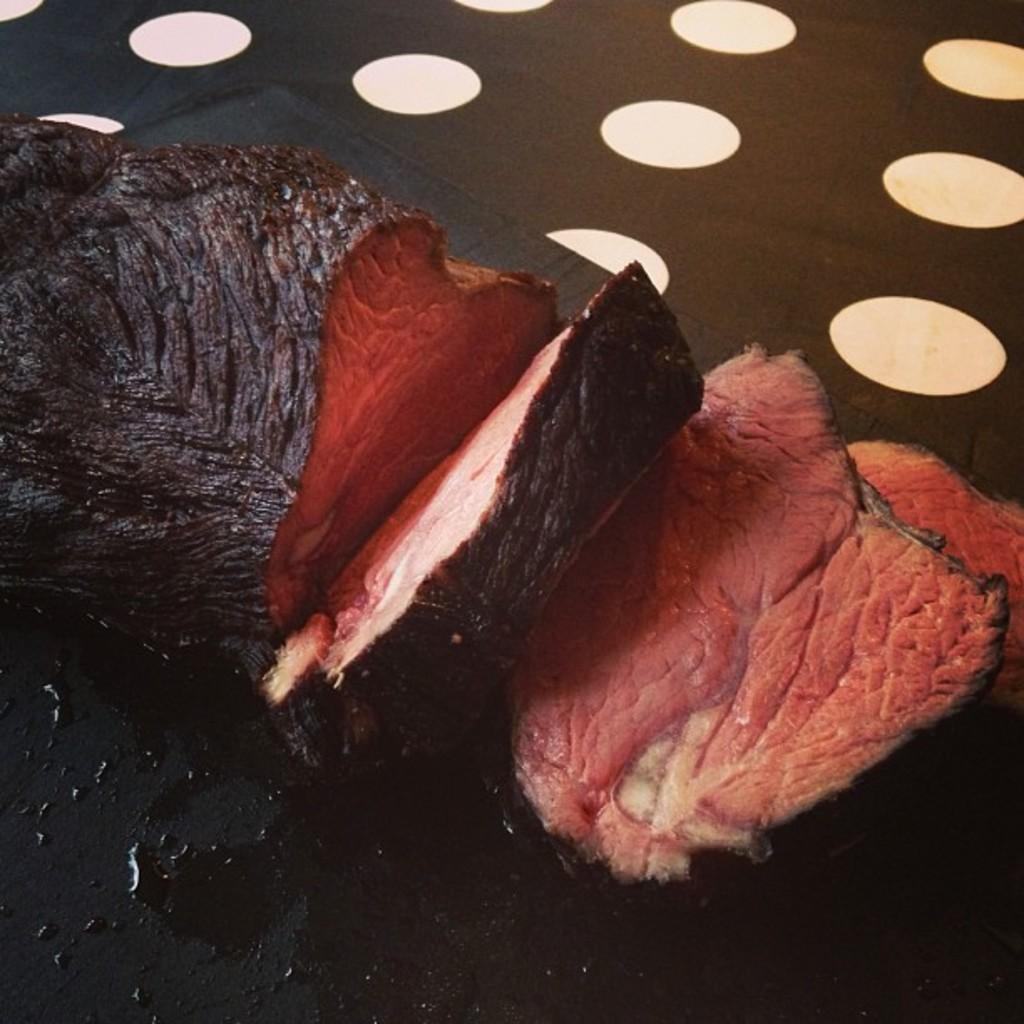Can you describe this image briefly? In this given picture, We can see flesh after that, We can a black surface and lights. 